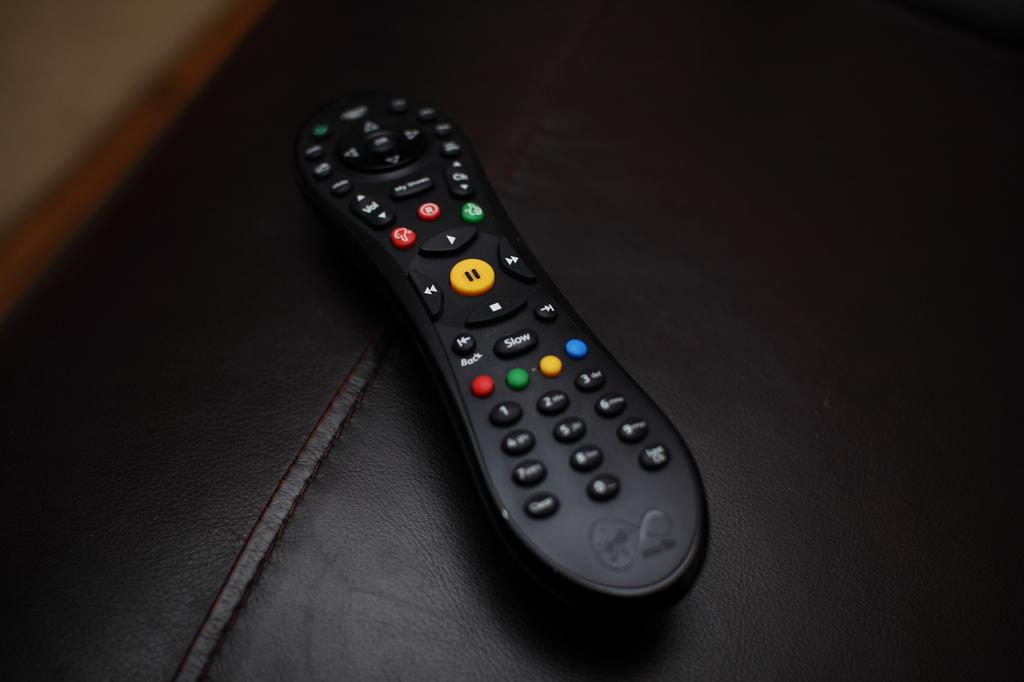Provide a one-sentence caption for the provided image. A black remote with a button that says Slow is sitting a black leather couch. 